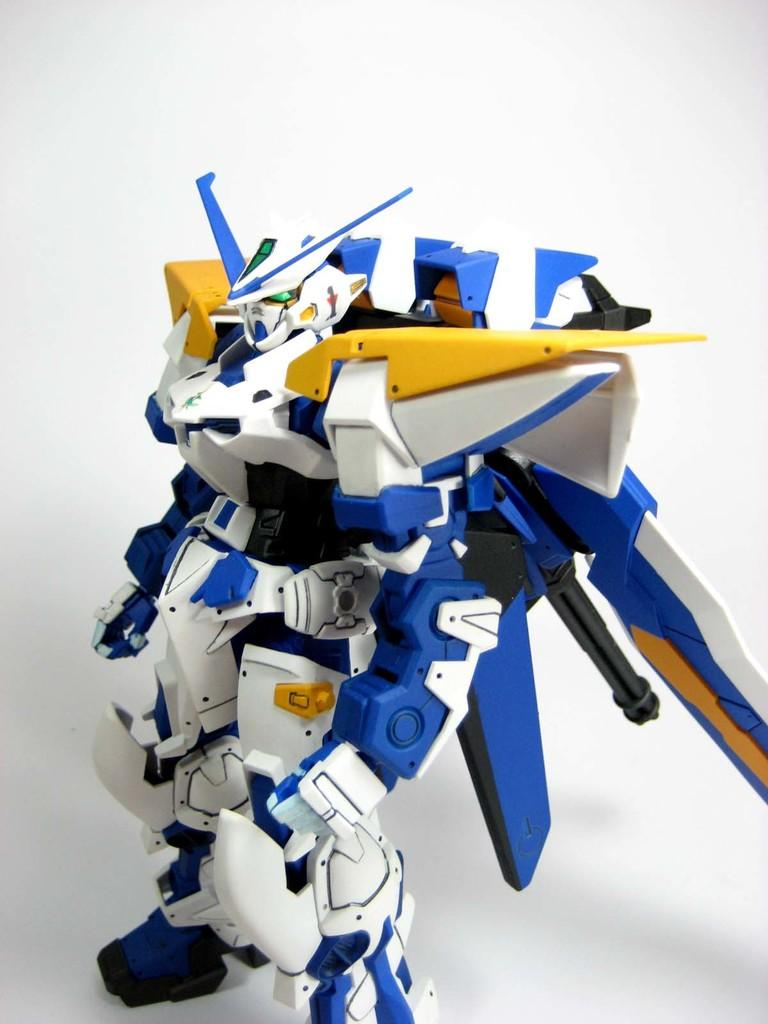What is the main subject of the image? The main subject of the image is a robot. What colors can be seen on the robot? The robot is in blue, white, and yellow colors. What can be seen in the background of the image? There is a wall in the background of the image. How much payment is required to use the robot in the image? There is no mention of payment or any transaction related to the robot in the image. 